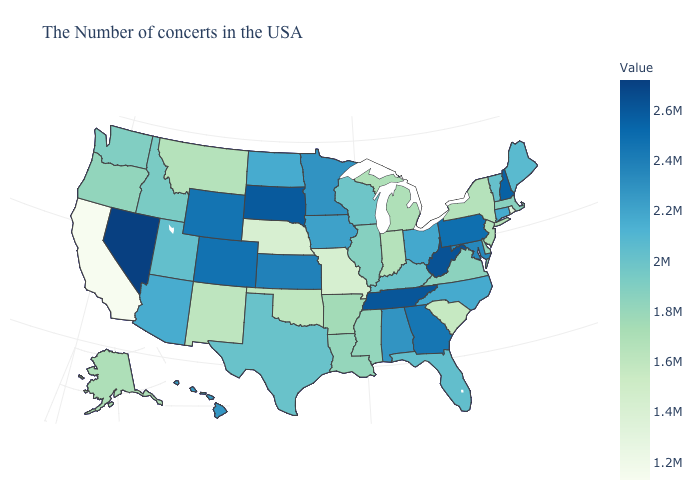Does California have the lowest value in the West?
Write a very short answer. Yes. Which states have the lowest value in the USA?
Give a very brief answer. California. Does Vermont have a higher value than California?
Write a very short answer. Yes. 